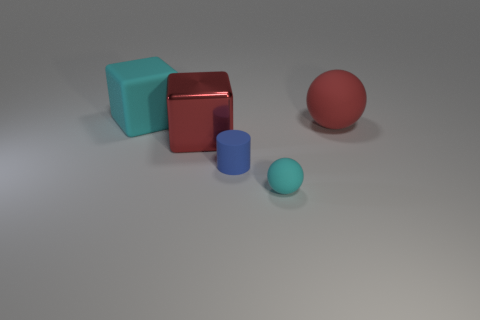Subtract all red spheres. How many spheres are left? 1 Subtract all cylinders. How many objects are left? 4 Subtract 1 cylinders. How many cylinders are left? 0 Add 3 large shiny cubes. How many objects exist? 8 Subtract all blue spheres. How many gray cylinders are left? 0 Subtract 0 blue spheres. How many objects are left? 5 Subtract all brown cylinders. Subtract all cyan spheres. How many cylinders are left? 1 Subtract all large brown blocks. Subtract all cyan rubber cubes. How many objects are left? 4 Add 1 red rubber balls. How many red rubber balls are left? 2 Add 5 green rubber balls. How many green rubber balls exist? 5 